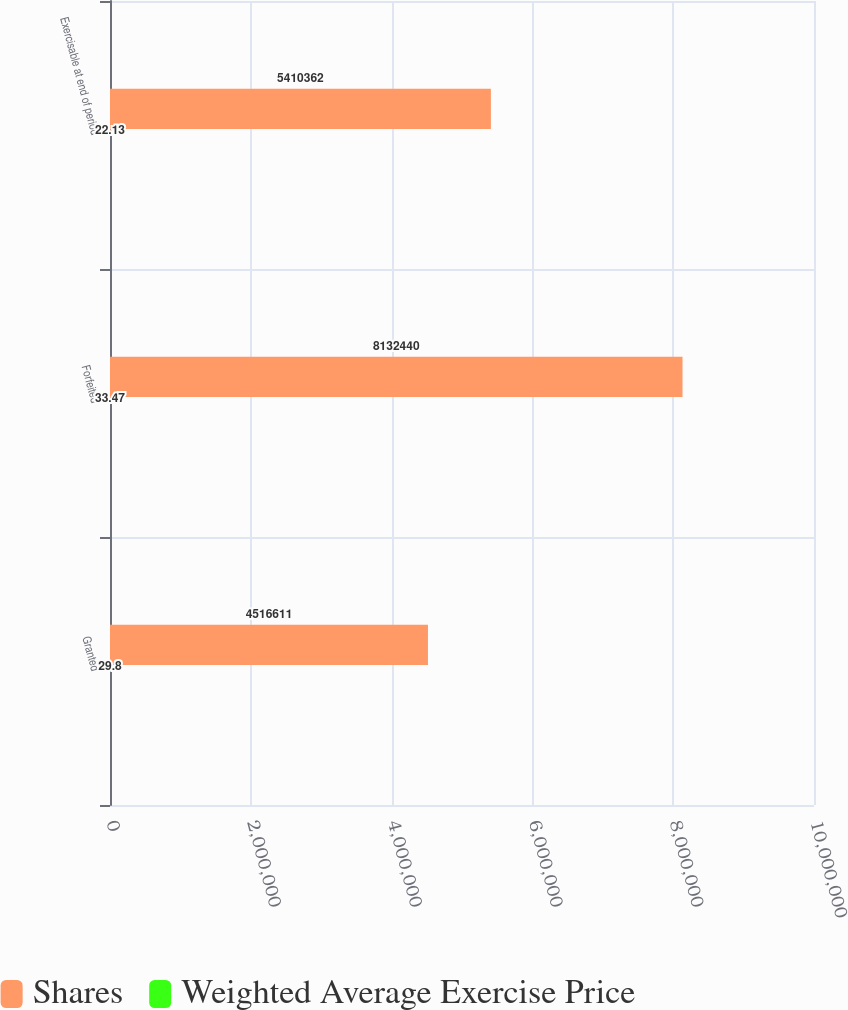Convert chart. <chart><loc_0><loc_0><loc_500><loc_500><stacked_bar_chart><ecel><fcel>Granted<fcel>Forfeited<fcel>Exercisable at end of period<nl><fcel>Shares<fcel>4.51661e+06<fcel>8.13244e+06<fcel>5.41036e+06<nl><fcel>Weighted Average Exercise Price<fcel>29.8<fcel>33.47<fcel>22.13<nl></chart> 